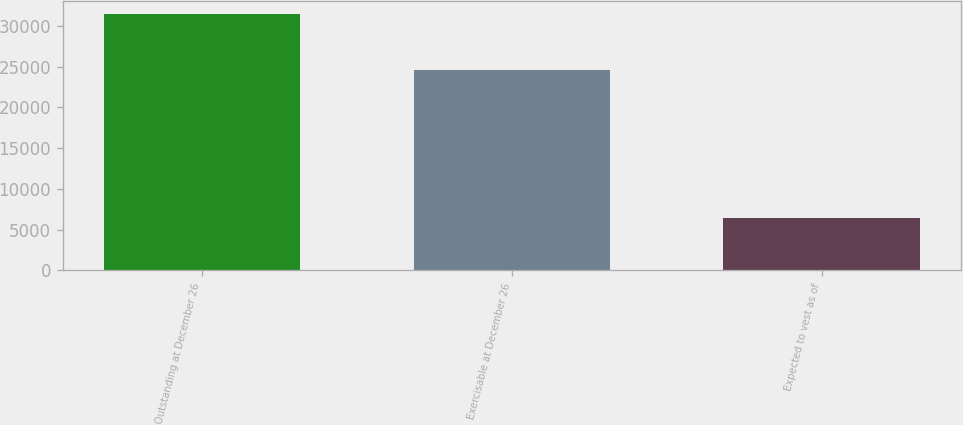<chart> <loc_0><loc_0><loc_500><loc_500><bar_chart><fcel>Outstanding at December 26<fcel>Exercisable at December 26<fcel>Expected to vest as of<nl><fcel>31472<fcel>24609<fcel>6365<nl></chart> 